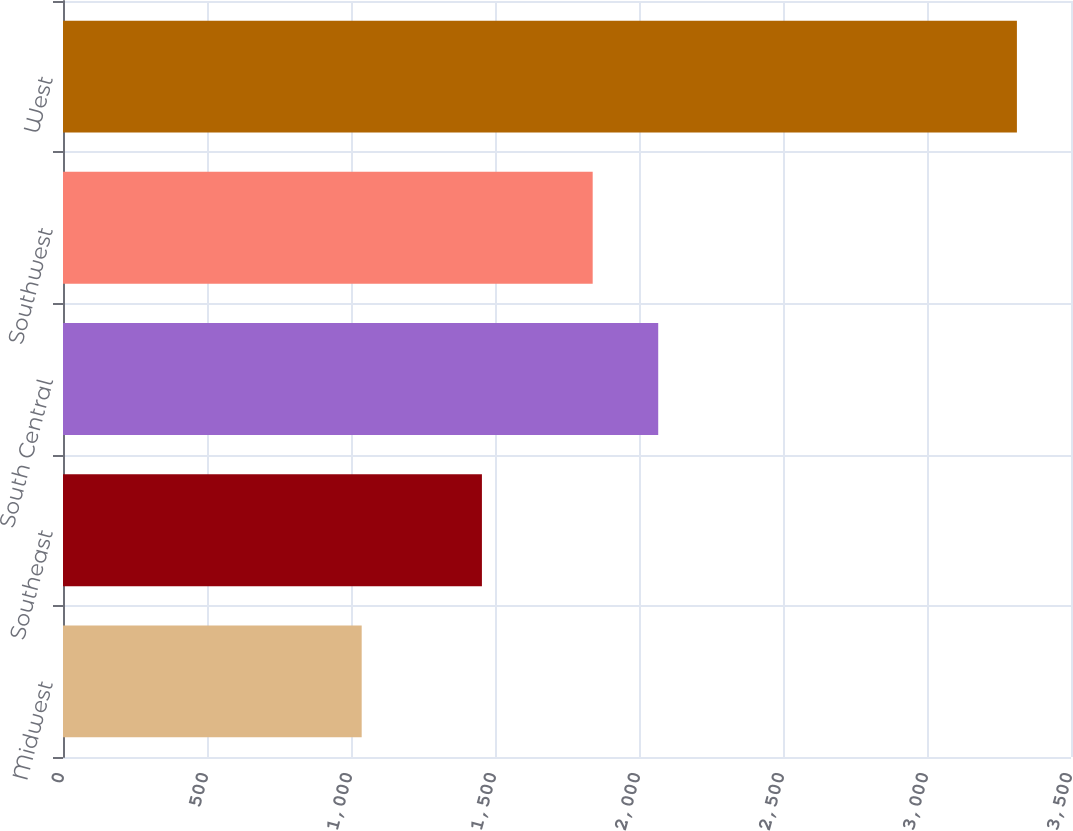Convert chart. <chart><loc_0><loc_0><loc_500><loc_500><bar_chart><fcel>Midwest<fcel>Southeast<fcel>South Central<fcel>Southwest<fcel>West<nl><fcel>1037.1<fcel>1454.6<fcel>2066.71<fcel>1839.2<fcel>3312.2<nl></chart> 